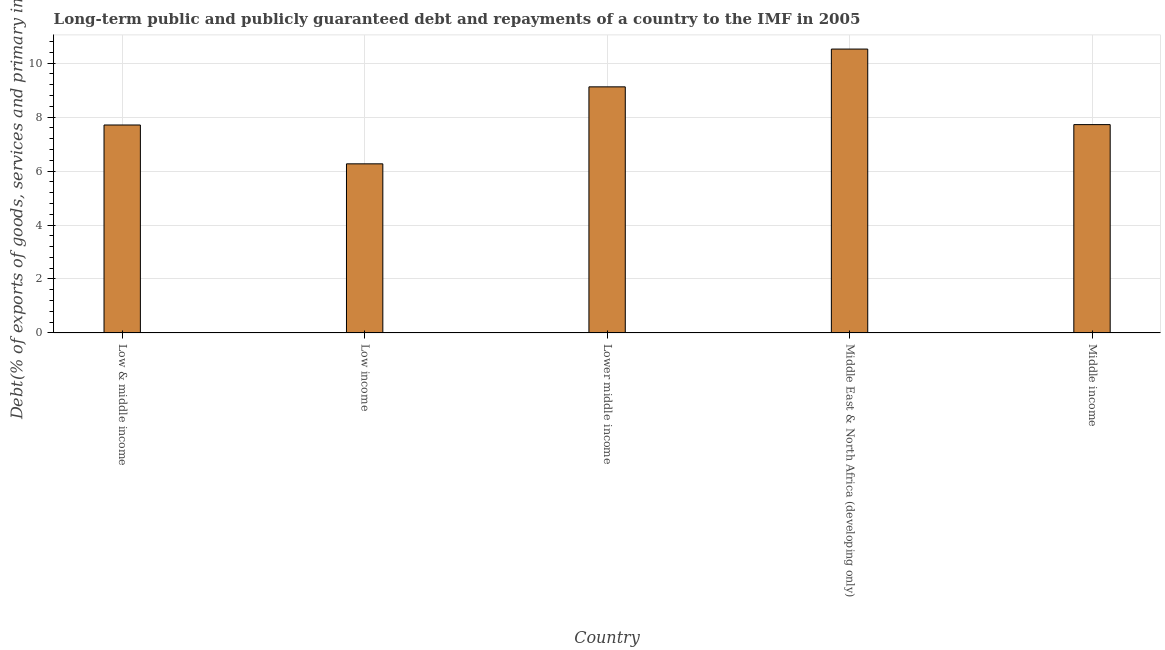What is the title of the graph?
Provide a short and direct response. Long-term public and publicly guaranteed debt and repayments of a country to the IMF in 2005. What is the label or title of the X-axis?
Ensure brevity in your answer.  Country. What is the label or title of the Y-axis?
Your response must be concise. Debt(% of exports of goods, services and primary income). What is the debt service in Lower middle income?
Provide a succinct answer. 9.12. Across all countries, what is the maximum debt service?
Keep it short and to the point. 10.52. Across all countries, what is the minimum debt service?
Provide a short and direct response. 6.27. In which country was the debt service maximum?
Provide a succinct answer. Middle East & North Africa (developing only). In which country was the debt service minimum?
Offer a very short reply. Low income. What is the sum of the debt service?
Offer a very short reply. 41.34. What is the difference between the debt service in Low & middle income and Low income?
Provide a short and direct response. 1.44. What is the average debt service per country?
Ensure brevity in your answer.  8.27. What is the median debt service?
Offer a very short reply. 7.72. What is the ratio of the debt service in Lower middle income to that in Middle income?
Your response must be concise. 1.18. Is the difference between the debt service in Lower middle income and Middle East & North Africa (developing only) greater than the difference between any two countries?
Give a very brief answer. No. What is the difference between the highest and the second highest debt service?
Your response must be concise. 1.4. Is the sum of the debt service in Low & middle income and Lower middle income greater than the maximum debt service across all countries?
Ensure brevity in your answer.  Yes. What is the difference between the highest and the lowest debt service?
Your response must be concise. 4.25. How many countries are there in the graph?
Your answer should be compact. 5. What is the Debt(% of exports of goods, services and primary income) in Low & middle income?
Ensure brevity in your answer.  7.71. What is the Debt(% of exports of goods, services and primary income) of Low income?
Ensure brevity in your answer.  6.27. What is the Debt(% of exports of goods, services and primary income) in Lower middle income?
Provide a succinct answer. 9.12. What is the Debt(% of exports of goods, services and primary income) of Middle East & North Africa (developing only)?
Offer a terse response. 10.52. What is the Debt(% of exports of goods, services and primary income) of Middle income?
Your response must be concise. 7.72. What is the difference between the Debt(% of exports of goods, services and primary income) in Low & middle income and Low income?
Offer a very short reply. 1.44. What is the difference between the Debt(% of exports of goods, services and primary income) in Low & middle income and Lower middle income?
Your response must be concise. -1.41. What is the difference between the Debt(% of exports of goods, services and primary income) in Low & middle income and Middle East & North Africa (developing only)?
Give a very brief answer. -2.81. What is the difference between the Debt(% of exports of goods, services and primary income) in Low & middle income and Middle income?
Your answer should be very brief. -0.01. What is the difference between the Debt(% of exports of goods, services and primary income) in Low income and Lower middle income?
Give a very brief answer. -2.85. What is the difference between the Debt(% of exports of goods, services and primary income) in Low income and Middle East & North Africa (developing only)?
Ensure brevity in your answer.  -4.25. What is the difference between the Debt(% of exports of goods, services and primary income) in Low income and Middle income?
Your response must be concise. -1.45. What is the difference between the Debt(% of exports of goods, services and primary income) in Lower middle income and Middle East & North Africa (developing only)?
Provide a short and direct response. -1.4. What is the difference between the Debt(% of exports of goods, services and primary income) in Lower middle income and Middle income?
Offer a terse response. 1.4. What is the difference between the Debt(% of exports of goods, services and primary income) in Middle East & North Africa (developing only) and Middle income?
Your answer should be very brief. 2.8. What is the ratio of the Debt(% of exports of goods, services and primary income) in Low & middle income to that in Low income?
Your answer should be very brief. 1.23. What is the ratio of the Debt(% of exports of goods, services and primary income) in Low & middle income to that in Lower middle income?
Offer a very short reply. 0.84. What is the ratio of the Debt(% of exports of goods, services and primary income) in Low & middle income to that in Middle East & North Africa (developing only)?
Provide a short and direct response. 0.73. What is the ratio of the Debt(% of exports of goods, services and primary income) in Low income to that in Lower middle income?
Keep it short and to the point. 0.69. What is the ratio of the Debt(% of exports of goods, services and primary income) in Low income to that in Middle East & North Africa (developing only)?
Offer a very short reply. 0.6. What is the ratio of the Debt(% of exports of goods, services and primary income) in Low income to that in Middle income?
Your response must be concise. 0.81. What is the ratio of the Debt(% of exports of goods, services and primary income) in Lower middle income to that in Middle East & North Africa (developing only)?
Offer a very short reply. 0.87. What is the ratio of the Debt(% of exports of goods, services and primary income) in Lower middle income to that in Middle income?
Provide a succinct answer. 1.18. What is the ratio of the Debt(% of exports of goods, services and primary income) in Middle East & North Africa (developing only) to that in Middle income?
Offer a very short reply. 1.36. 